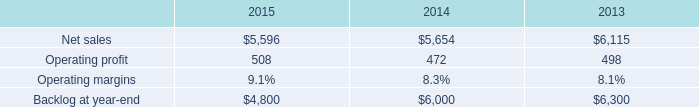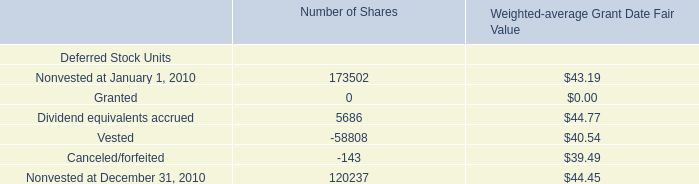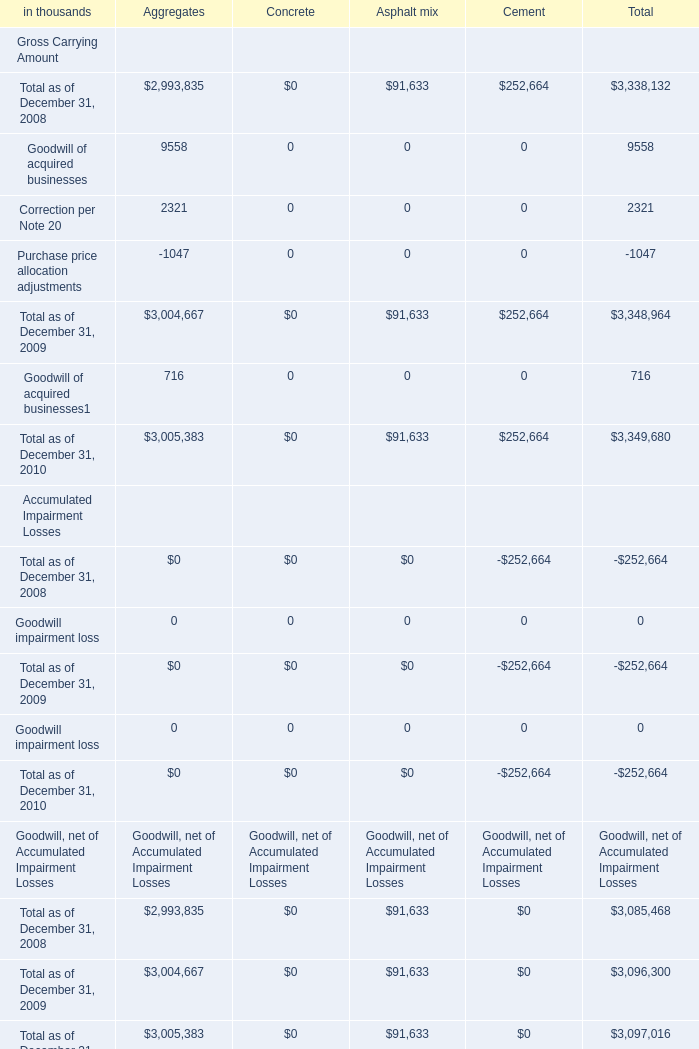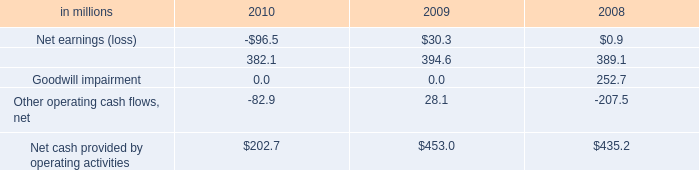Which year is Aggregates the lowest for Goodwill, net of Accumulated Impairment Losses? 
Answer: 2008. 